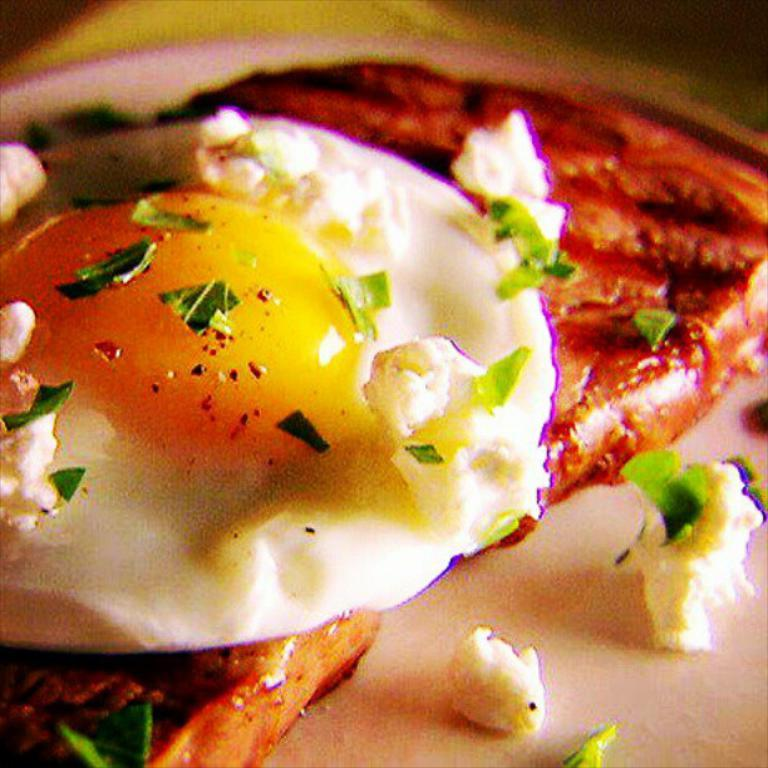What is the focus of the image? The image is zoomed in on a half boiled egg in the center. What else can be seen in the image besides the egg? There are food items visible in the image. What advice can be given to the spiders in the image? There are no spiders present in the image, so no advice can be given to them. 